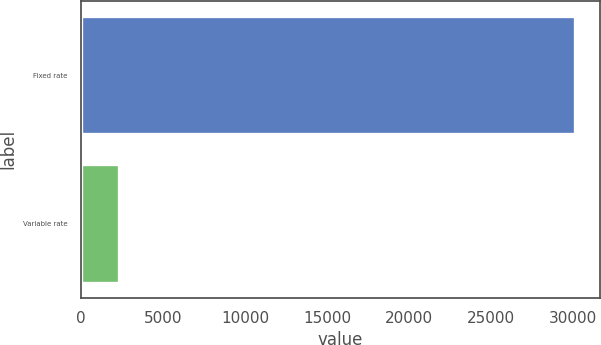<chart> <loc_0><loc_0><loc_500><loc_500><bar_chart><fcel>Fixed rate<fcel>Variable rate<nl><fcel>30132<fcel>2324<nl></chart> 